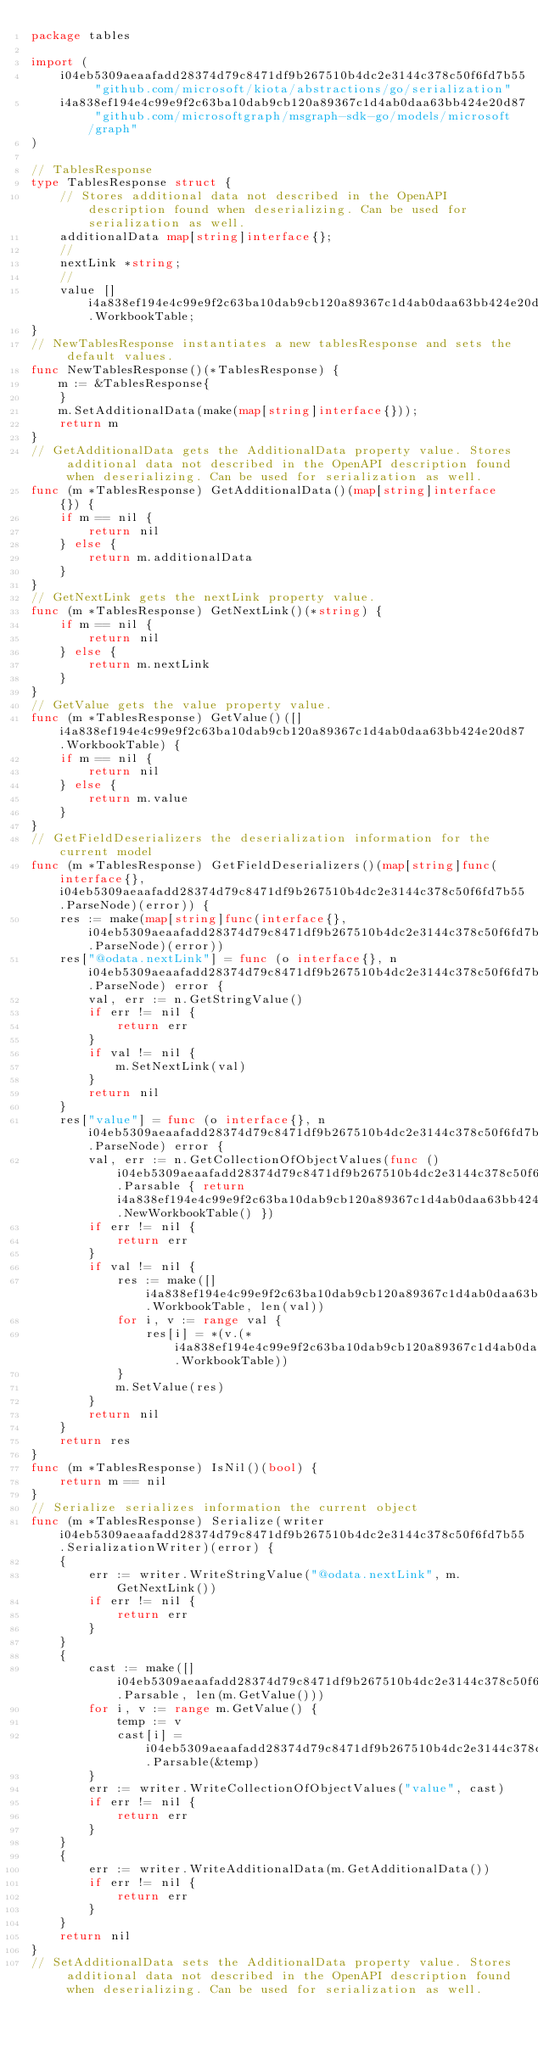Convert code to text. <code><loc_0><loc_0><loc_500><loc_500><_Go_>package tables

import (
    i04eb5309aeaafadd28374d79c8471df9b267510b4dc2e3144c378c50f6fd7b55 "github.com/microsoft/kiota/abstractions/go/serialization"
    i4a838ef194e4c99e9f2c63ba10dab9cb120a89367c1d4ab0daa63bb424e20d87 "github.com/microsoftgraph/msgraph-sdk-go/models/microsoft/graph"
)

// TablesResponse 
type TablesResponse struct {
    // Stores additional data not described in the OpenAPI description found when deserializing. Can be used for serialization as well.
    additionalData map[string]interface{};
    // 
    nextLink *string;
    // 
    value []i4a838ef194e4c99e9f2c63ba10dab9cb120a89367c1d4ab0daa63bb424e20d87.WorkbookTable;
}
// NewTablesResponse instantiates a new tablesResponse and sets the default values.
func NewTablesResponse()(*TablesResponse) {
    m := &TablesResponse{
    }
    m.SetAdditionalData(make(map[string]interface{}));
    return m
}
// GetAdditionalData gets the AdditionalData property value. Stores additional data not described in the OpenAPI description found when deserializing. Can be used for serialization as well.
func (m *TablesResponse) GetAdditionalData()(map[string]interface{}) {
    if m == nil {
        return nil
    } else {
        return m.additionalData
    }
}
// GetNextLink gets the nextLink property value. 
func (m *TablesResponse) GetNextLink()(*string) {
    if m == nil {
        return nil
    } else {
        return m.nextLink
    }
}
// GetValue gets the value property value. 
func (m *TablesResponse) GetValue()([]i4a838ef194e4c99e9f2c63ba10dab9cb120a89367c1d4ab0daa63bb424e20d87.WorkbookTable) {
    if m == nil {
        return nil
    } else {
        return m.value
    }
}
// GetFieldDeserializers the deserialization information for the current model
func (m *TablesResponse) GetFieldDeserializers()(map[string]func(interface{}, i04eb5309aeaafadd28374d79c8471df9b267510b4dc2e3144c378c50f6fd7b55.ParseNode)(error)) {
    res := make(map[string]func(interface{}, i04eb5309aeaafadd28374d79c8471df9b267510b4dc2e3144c378c50f6fd7b55.ParseNode)(error))
    res["@odata.nextLink"] = func (o interface{}, n i04eb5309aeaafadd28374d79c8471df9b267510b4dc2e3144c378c50f6fd7b55.ParseNode) error {
        val, err := n.GetStringValue()
        if err != nil {
            return err
        }
        if val != nil {
            m.SetNextLink(val)
        }
        return nil
    }
    res["value"] = func (o interface{}, n i04eb5309aeaafadd28374d79c8471df9b267510b4dc2e3144c378c50f6fd7b55.ParseNode) error {
        val, err := n.GetCollectionOfObjectValues(func () i04eb5309aeaafadd28374d79c8471df9b267510b4dc2e3144c378c50f6fd7b55.Parsable { return i4a838ef194e4c99e9f2c63ba10dab9cb120a89367c1d4ab0daa63bb424e20d87.NewWorkbookTable() })
        if err != nil {
            return err
        }
        if val != nil {
            res := make([]i4a838ef194e4c99e9f2c63ba10dab9cb120a89367c1d4ab0daa63bb424e20d87.WorkbookTable, len(val))
            for i, v := range val {
                res[i] = *(v.(*i4a838ef194e4c99e9f2c63ba10dab9cb120a89367c1d4ab0daa63bb424e20d87.WorkbookTable))
            }
            m.SetValue(res)
        }
        return nil
    }
    return res
}
func (m *TablesResponse) IsNil()(bool) {
    return m == nil
}
// Serialize serializes information the current object
func (m *TablesResponse) Serialize(writer i04eb5309aeaafadd28374d79c8471df9b267510b4dc2e3144c378c50f6fd7b55.SerializationWriter)(error) {
    {
        err := writer.WriteStringValue("@odata.nextLink", m.GetNextLink())
        if err != nil {
            return err
        }
    }
    {
        cast := make([]i04eb5309aeaafadd28374d79c8471df9b267510b4dc2e3144c378c50f6fd7b55.Parsable, len(m.GetValue()))
        for i, v := range m.GetValue() {
            temp := v
            cast[i] = i04eb5309aeaafadd28374d79c8471df9b267510b4dc2e3144c378c50f6fd7b55.Parsable(&temp)
        }
        err := writer.WriteCollectionOfObjectValues("value", cast)
        if err != nil {
            return err
        }
    }
    {
        err := writer.WriteAdditionalData(m.GetAdditionalData())
        if err != nil {
            return err
        }
    }
    return nil
}
// SetAdditionalData sets the AdditionalData property value. Stores additional data not described in the OpenAPI description found when deserializing. Can be used for serialization as well.</code> 